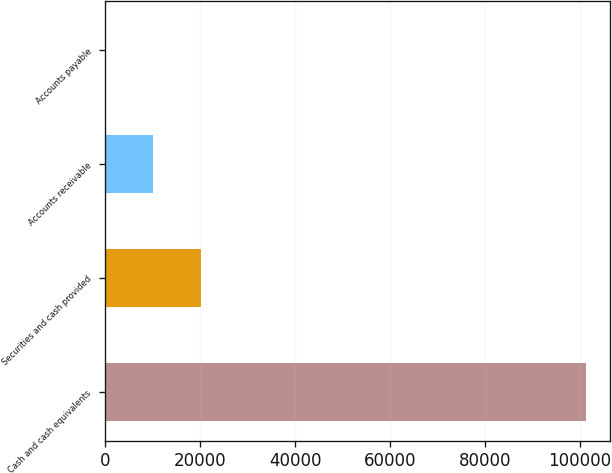Convert chart. <chart><loc_0><loc_0><loc_500><loc_500><bar_chart><fcel>Cash and cash equivalents<fcel>Securities and cash provided<fcel>Accounts receivable<fcel>Accounts payable<nl><fcel>101273<fcel>20277.8<fcel>10153.4<fcel>29<nl></chart> 